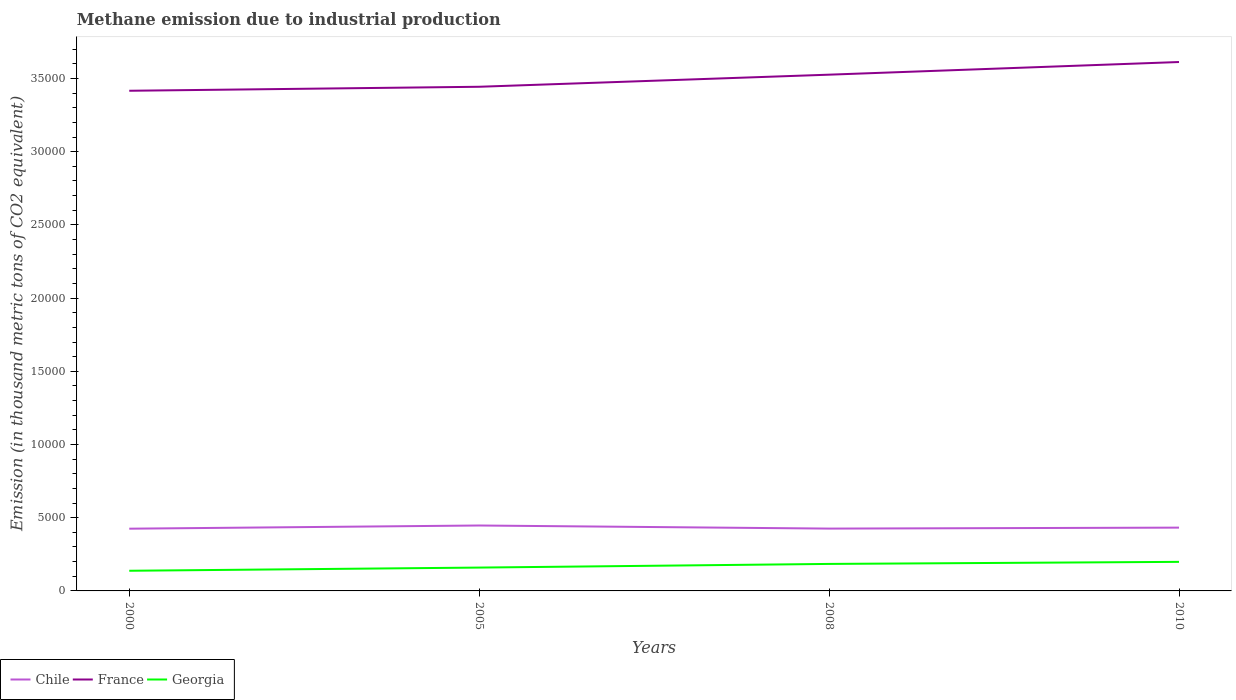How many different coloured lines are there?
Ensure brevity in your answer.  3. Is the number of lines equal to the number of legend labels?
Ensure brevity in your answer.  Yes. Across all years, what is the maximum amount of methane emitted in Chile?
Ensure brevity in your answer.  4250.2. What is the total amount of methane emitted in Georgia in the graph?
Your answer should be very brief. -467.6. What is the difference between the highest and the second highest amount of methane emitted in Chile?
Your answer should be very brief. 217.8. What is the difference between the highest and the lowest amount of methane emitted in France?
Give a very brief answer. 2. Is the amount of methane emitted in Chile strictly greater than the amount of methane emitted in Georgia over the years?
Ensure brevity in your answer.  No. How many lines are there?
Provide a short and direct response. 3. How many years are there in the graph?
Your answer should be very brief. 4. What is the difference between two consecutive major ticks on the Y-axis?
Your answer should be compact. 5000. Are the values on the major ticks of Y-axis written in scientific E-notation?
Give a very brief answer. No. Does the graph contain grids?
Give a very brief answer. No. How many legend labels are there?
Your response must be concise. 3. How are the legend labels stacked?
Provide a succinct answer. Horizontal. What is the title of the graph?
Give a very brief answer. Methane emission due to industrial production. Does "Romania" appear as one of the legend labels in the graph?
Provide a succinct answer. No. What is the label or title of the Y-axis?
Keep it short and to the point. Emission (in thousand metric tons of CO2 equivalent). What is the Emission (in thousand metric tons of CO2 equivalent) of Chile in 2000?
Your answer should be very brief. 4250.2. What is the Emission (in thousand metric tons of CO2 equivalent) of France in 2000?
Ensure brevity in your answer.  3.42e+04. What is the Emission (in thousand metric tons of CO2 equivalent) in Georgia in 2000?
Give a very brief answer. 1376.9. What is the Emission (in thousand metric tons of CO2 equivalent) in Chile in 2005?
Your response must be concise. 4468. What is the Emission (in thousand metric tons of CO2 equivalent) of France in 2005?
Your answer should be compact. 3.44e+04. What is the Emission (in thousand metric tons of CO2 equivalent) of Georgia in 2005?
Your answer should be compact. 1594.3. What is the Emission (in thousand metric tons of CO2 equivalent) in Chile in 2008?
Your answer should be very brief. 4257. What is the Emission (in thousand metric tons of CO2 equivalent) of France in 2008?
Ensure brevity in your answer.  3.53e+04. What is the Emission (in thousand metric tons of CO2 equivalent) of Georgia in 2008?
Offer a terse response. 1844.5. What is the Emission (in thousand metric tons of CO2 equivalent) in Chile in 2010?
Provide a short and direct response. 4322.9. What is the Emission (in thousand metric tons of CO2 equivalent) in France in 2010?
Offer a terse response. 3.61e+04. What is the Emission (in thousand metric tons of CO2 equivalent) in Georgia in 2010?
Your answer should be very brief. 1985.2. Across all years, what is the maximum Emission (in thousand metric tons of CO2 equivalent) of Chile?
Provide a succinct answer. 4468. Across all years, what is the maximum Emission (in thousand metric tons of CO2 equivalent) in France?
Your answer should be compact. 3.61e+04. Across all years, what is the maximum Emission (in thousand metric tons of CO2 equivalent) of Georgia?
Your answer should be very brief. 1985.2. Across all years, what is the minimum Emission (in thousand metric tons of CO2 equivalent) of Chile?
Give a very brief answer. 4250.2. Across all years, what is the minimum Emission (in thousand metric tons of CO2 equivalent) of France?
Keep it short and to the point. 3.42e+04. Across all years, what is the minimum Emission (in thousand metric tons of CO2 equivalent) of Georgia?
Give a very brief answer. 1376.9. What is the total Emission (in thousand metric tons of CO2 equivalent) of Chile in the graph?
Provide a short and direct response. 1.73e+04. What is the total Emission (in thousand metric tons of CO2 equivalent) of France in the graph?
Your answer should be compact. 1.40e+05. What is the total Emission (in thousand metric tons of CO2 equivalent) in Georgia in the graph?
Keep it short and to the point. 6800.9. What is the difference between the Emission (in thousand metric tons of CO2 equivalent) in Chile in 2000 and that in 2005?
Offer a terse response. -217.8. What is the difference between the Emission (in thousand metric tons of CO2 equivalent) in France in 2000 and that in 2005?
Give a very brief answer. -272.3. What is the difference between the Emission (in thousand metric tons of CO2 equivalent) of Georgia in 2000 and that in 2005?
Your answer should be compact. -217.4. What is the difference between the Emission (in thousand metric tons of CO2 equivalent) of Chile in 2000 and that in 2008?
Give a very brief answer. -6.8. What is the difference between the Emission (in thousand metric tons of CO2 equivalent) in France in 2000 and that in 2008?
Your answer should be very brief. -1098.9. What is the difference between the Emission (in thousand metric tons of CO2 equivalent) in Georgia in 2000 and that in 2008?
Provide a succinct answer. -467.6. What is the difference between the Emission (in thousand metric tons of CO2 equivalent) of Chile in 2000 and that in 2010?
Your answer should be very brief. -72.7. What is the difference between the Emission (in thousand metric tons of CO2 equivalent) of France in 2000 and that in 2010?
Provide a succinct answer. -1963.4. What is the difference between the Emission (in thousand metric tons of CO2 equivalent) of Georgia in 2000 and that in 2010?
Your answer should be compact. -608.3. What is the difference between the Emission (in thousand metric tons of CO2 equivalent) in Chile in 2005 and that in 2008?
Keep it short and to the point. 211. What is the difference between the Emission (in thousand metric tons of CO2 equivalent) in France in 2005 and that in 2008?
Your response must be concise. -826.6. What is the difference between the Emission (in thousand metric tons of CO2 equivalent) in Georgia in 2005 and that in 2008?
Offer a very short reply. -250.2. What is the difference between the Emission (in thousand metric tons of CO2 equivalent) of Chile in 2005 and that in 2010?
Your answer should be compact. 145.1. What is the difference between the Emission (in thousand metric tons of CO2 equivalent) in France in 2005 and that in 2010?
Keep it short and to the point. -1691.1. What is the difference between the Emission (in thousand metric tons of CO2 equivalent) of Georgia in 2005 and that in 2010?
Your answer should be compact. -390.9. What is the difference between the Emission (in thousand metric tons of CO2 equivalent) of Chile in 2008 and that in 2010?
Provide a short and direct response. -65.9. What is the difference between the Emission (in thousand metric tons of CO2 equivalent) in France in 2008 and that in 2010?
Your answer should be compact. -864.5. What is the difference between the Emission (in thousand metric tons of CO2 equivalent) of Georgia in 2008 and that in 2010?
Ensure brevity in your answer.  -140.7. What is the difference between the Emission (in thousand metric tons of CO2 equivalent) in Chile in 2000 and the Emission (in thousand metric tons of CO2 equivalent) in France in 2005?
Offer a terse response. -3.02e+04. What is the difference between the Emission (in thousand metric tons of CO2 equivalent) of Chile in 2000 and the Emission (in thousand metric tons of CO2 equivalent) of Georgia in 2005?
Offer a very short reply. 2655.9. What is the difference between the Emission (in thousand metric tons of CO2 equivalent) of France in 2000 and the Emission (in thousand metric tons of CO2 equivalent) of Georgia in 2005?
Ensure brevity in your answer.  3.26e+04. What is the difference between the Emission (in thousand metric tons of CO2 equivalent) in Chile in 2000 and the Emission (in thousand metric tons of CO2 equivalent) in France in 2008?
Your answer should be compact. -3.10e+04. What is the difference between the Emission (in thousand metric tons of CO2 equivalent) in Chile in 2000 and the Emission (in thousand metric tons of CO2 equivalent) in Georgia in 2008?
Keep it short and to the point. 2405.7. What is the difference between the Emission (in thousand metric tons of CO2 equivalent) of France in 2000 and the Emission (in thousand metric tons of CO2 equivalent) of Georgia in 2008?
Provide a short and direct response. 3.23e+04. What is the difference between the Emission (in thousand metric tons of CO2 equivalent) in Chile in 2000 and the Emission (in thousand metric tons of CO2 equivalent) in France in 2010?
Keep it short and to the point. -3.19e+04. What is the difference between the Emission (in thousand metric tons of CO2 equivalent) in Chile in 2000 and the Emission (in thousand metric tons of CO2 equivalent) in Georgia in 2010?
Provide a succinct answer. 2265. What is the difference between the Emission (in thousand metric tons of CO2 equivalent) of France in 2000 and the Emission (in thousand metric tons of CO2 equivalent) of Georgia in 2010?
Offer a very short reply. 3.22e+04. What is the difference between the Emission (in thousand metric tons of CO2 equivalent) of Chile in 2005 and the Emission (in thousand metric tons of CO2 equivalent) of France in 2008?
Your response must be concise. -3.08e+04. What is the difference between the Emission (in thousand metric tons of CO2 equivalent) in Chile in 2005 and the Emission (in thousand metric tons of CO2 equivalent) in Georgia in 2008?
Offer a very short reply. 2623.5. What is the difference between the Emission (in thousand metric tons of CO2 equivalent) in France in 2005 and the Emission (in thousand metric tons of CO2 equivalent) in Georgia in 2008?
Your response must be concise. 3.26e+04. What is the difference between the Emission (in thousand metric tons of CO2 equivalent) in Chile in 2005 and the Emission (in thousand metric tons of CO2 equivalent) in France in 2010?
Provide a short and direct response. -3.17e+04. What is the difference between the Emission (in thousand metric tons of CO2 equivalent) of Chile in 2005 and the Emission (in thousand metric tons of CO2 equivalent) of Georgia in 2010?
Ensure brevity in your answer.  2482.8. What is the difference between the Emission (in thousand metric tons of CO2 equivalent) in France in 2005 and the Emission (in thousand metric tons of CO2 equivalent) in Georgia in 2010?
Keep it short and to the point. 3.24e+04. What is the difference between the Emission (in thousand metric tons of CO2 equivalent) in Chile in 2008 and the Emission (in thousand metric tons of CO2 equivalent) in France in 2010?
Give a very brief answer. -3.19e+04. What is the difference between the Emission (in thousand metric tons of CO2 equivalent) of Chile in 2008 and the Emission (in thousand metric tons of CO2 equivalent) of Georgia in 2010?
Ensure brevity in your answer.  2271.8. What is the difference between the Emission (in thousand metric tons of CO2 equivalent) in France in 2008 and the Emission (in thousand metric tons of CO2 equivalent) in Georgia in 2010?
Keep it short and to the point. 3.33e+04. What is the average Emission (in thousand metric tons of CO2 equivalent) in Chile per year?
Offer a very short reply. 4324.52. What is the average Emission (in thousand metric tons of CO2 equivalent) of France per year?
Ensure brevity in your answer.  3.50e+04. What is the average Emission (in thousand metric tons of CO2 equivalent) of Georgia per year?
Provide a short and direct response. 1700.22. In the year 2000, what is the difference between the Emission (in thousand metric tons of CO2 equivalent) in Chile and Emission (in thousand metric tons of CO2 equivalent) in France?
Your answer should be very brief. -2.99e+04. In the year 2000, what is the difference between the Emission (in thousand metric tons of CO2 equivalent) in Chile and Emission (in thousand metric tons of CO2 equivalent) in Georgia?
Keep it short and to the point. 2873.3. In the year 2000, what is the difference between the Emission (in thousand metric tons of CO2 equivalent) in France and Emission (in thousand metric tons of CO2 equivalent) in Georgia?
Offer a terse response. 3.28e+04. In the year 2005, what is the difference between the Emission (in thousand metric tons of CO2 equivalent) of Chile and Emission (in thousand metric tons of CO2 equivalent) of France?
Your response must be concise. -3.00e+04. In the year 2005, what is the difference between the Emission (in thousand metric tons of CO2 equivalent) in Chile and Emission (in thousand metric tons of CO2 equivalent) in Georgia?
Offer a terse response. 2873.7. In the year 2005, what is the difference between the Emission (in thousand metric tons of CO2 equivalent) in France and Emission (in thousand metric tons of CO2 equivalent) in Georgia?
Your answer should be compact. 3.28e+04. In the year 2008, what is the difference between the Emission (in thousand metric tons of CO2 equivalent) of Chile and Emission (in thousand metric tons of CO2 equivalent) of France?
Ensure brevity in your answer.  -3.10e+04. In the year 2008, what is the difference between the Emission (in thousand metric tons of CO2 equivalent) in Chile and Emission (in thousand metric tons of CO2 equivalent) in Georgia?
Keep it short and to the point. 2412.5. In the year 2008, what is the difference between the Emission (in thousand metric tons of CO2 equivalent) in France and Emission (in thousand metric tons of CO2 equivalent) in Georgia?
Provide a succinct answer. 3.34e+04. In the year 2010, what is the difference between the Emission (in thousand metric tons of CO2 equivalent) of Chile and Emission (in thousand metric tons of CO2 equivalent) of France?
Provide a short and direct response. -3.18e+04. In the year 2010, what is the difference between the Emission (in thousand metric tons of CO2 equivalent) of Chile and Emission (in thousand metric tons of CO2 equivalent) of Georgia?
Ensure brevity in your answer.  2337.7. In the year 2010, what is the difference between the Emission (in thousand metric tons of CO2 equivalent) of France and Emission (in thousand metric tons of CO2 equivalent) of Georgia?
Keep it short and to the point. 3.41e+04. What is the ratio of the Emission (in thousand metric tons of CO2 equivalent) of Chile in 2000 to that in 2005?
Give a very brief answer. 0.95. What is the ratio of the Emission (in thousand metric tons of CO2 equivalent) in France in 2000 to that in 2005?
Provide a short and direct response. 0.99. What is the ratio of the Emission (in thousand metric tons of CO2 equivalent) of Georgia in 2000 to that in 2005?
Give a very brief answer. 0.86. What is the ratio of the Emission (in thousand metric tons of CO2 equivalent) in Chile in 2000 to that in 2008?
Make the answer very short. 1. What is the ratio of the Emission (in thousand metric tons of CO2 equivalent) of France in 2000 to that in 2008?
Your response must be concise. 0.97. What is the ratio of the Emission (in thousand metric tons of CO2 equivalent) in Georgia in 2000 to that in 2008?
Ensure brevity in your answer.  0.75. What is the ratio of the Emission (in thousand metric tons of CO2 equivalent) of Chile in 2000 to that in 2010?
Your response must be concise. 0.98. What is the ratio of the Emission (in thousand metric tons of CO2 equivalent) of France in 2000 to that in 2010?
Your answer should be very brief. 0.95. What is the ratio of the Emission (in thousand metric tons of CO2 equivalent) of Georgia in 2000 to that in 2010?
Your answer should be compact. 0.69. What is the ratio of the Emission (in thousand metric tons of CO2 equivalent) in Chile in 2005 to that in 2008?
Ensure brevity in your answer.  1.05. What is the ratio of the Emission (in thousand metric tons of CO2 equivalent) in France in 2005 to that in 2008?
Your response must be concise. 0.98. What is the ratio of the Emission (in thousand metric tons of CO2 equivalent) in Georgia in 2005 to that in 2008?
Provide a succinct answer. 0.86. What is the ratio of the Emission (in thousand metric tons of CO2 equivalent) of Chile in 2005 to that in 2010?
Offer a very short reply. 1.03. What is the ratio of the Emission (in thousand metric tons of CO2 equivalent) in France in 2005 to that in 2010?
Your answer should be compact. 0.95. What is the ratio of the Emission (in thousand metric tons of CO2 equivalent) of Georgia in 2005 to that in 2010?
Offer a terse response. 0.8. What is the ratio of the Emission (in thousand metric tons of CO2 equivalent) in France in 2008 to that in 2010?
Offer a terse response. 0.98. What is the ratio of the Emission (in thousand metric tons of CO2 equivalent) in Georgia in 2008 to that in 2010?
Offer a terse response. 0.93. What is the difference between the highest and the second highest Emission (in thousand metric tons of CO2 equivalent) in Chile?
Provide a short and direct response. 145.1. What is the difference between the highest and the second highest Emission (in thousand metric tons of CO2 equivalent) in France?
Give a very brief answer. 864.5. What is the difference between the highest and the second highest Emission (in thousand metric tons of CO2 equivalent) in Georgia?
Offer a terse response. 140.7. What is the difference between the highest and the lowest Emission (in thousand metric tons of CO2 equivalent) of Chile?
Your response must be concise. 217.8. What is the difference between the highest and the lowest Emission (in thousand metric tons of CO2 equivalent) of France?
Your answer should be very brief. 1963.4. What is the difference between the highest and the lowest Emission (in thousand metric tons of CO2 equivalent) of Georgia?
Your answer should be compact. 608.3. 